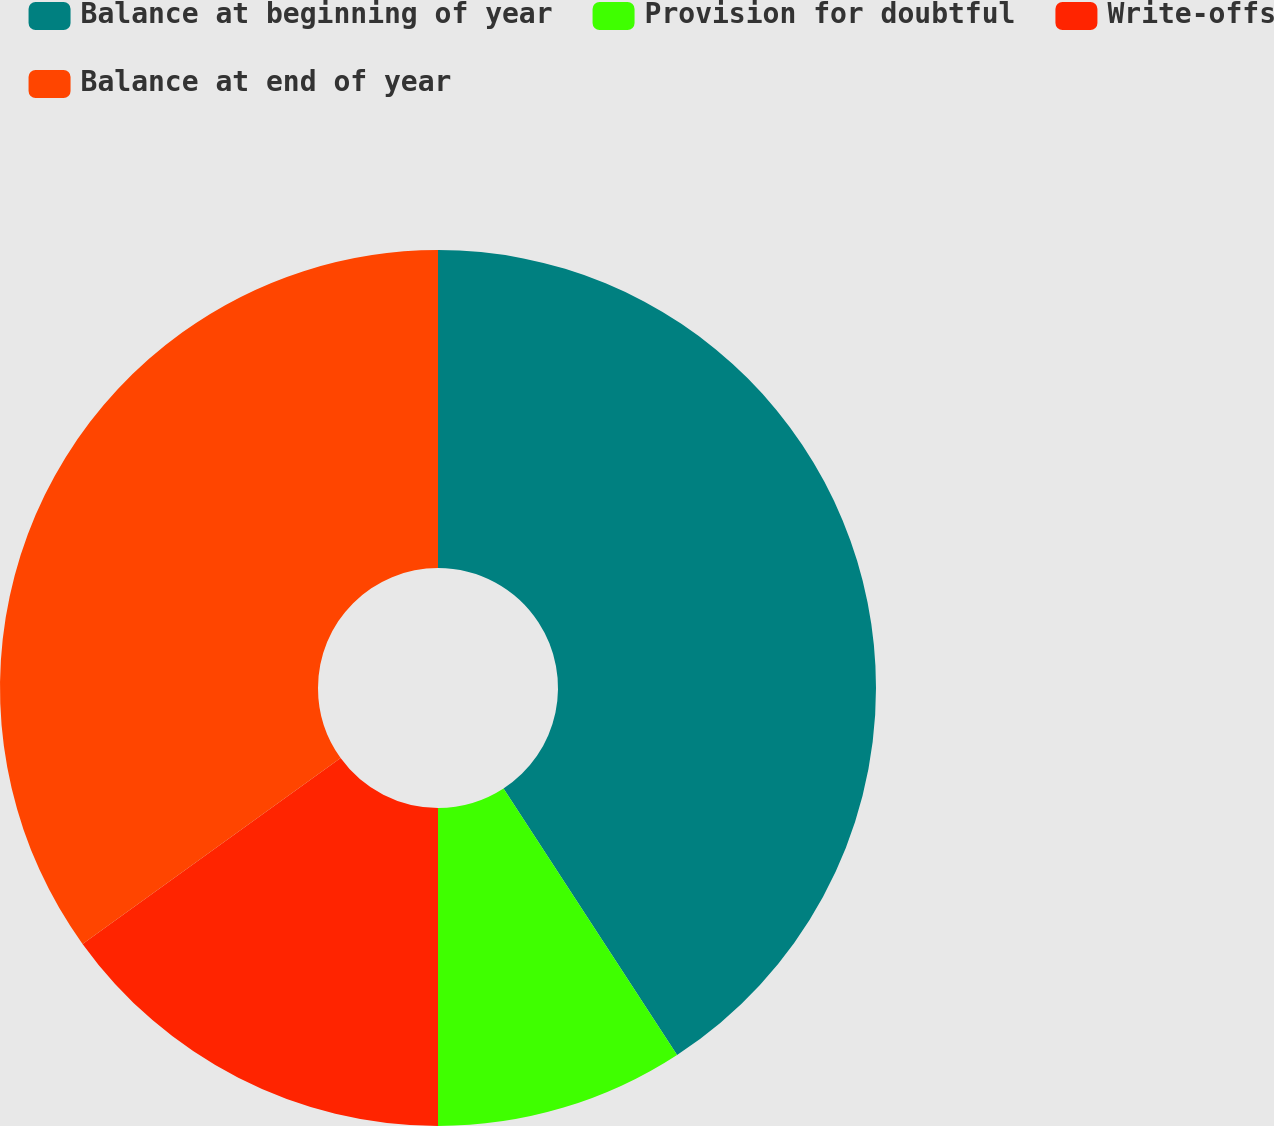Convert chart. <chart><loc_0><loc_0><loc_500><loc_500><pie_chart><fcel>Balance at beginning of year<fcel>Provision for doubtful<fcel>Write-offs<fcel>Balance at end of year<nl><fcel>40.81%<fcel>9.19%<fcel>15.07%<fcel>34.93%<nl></chart> 